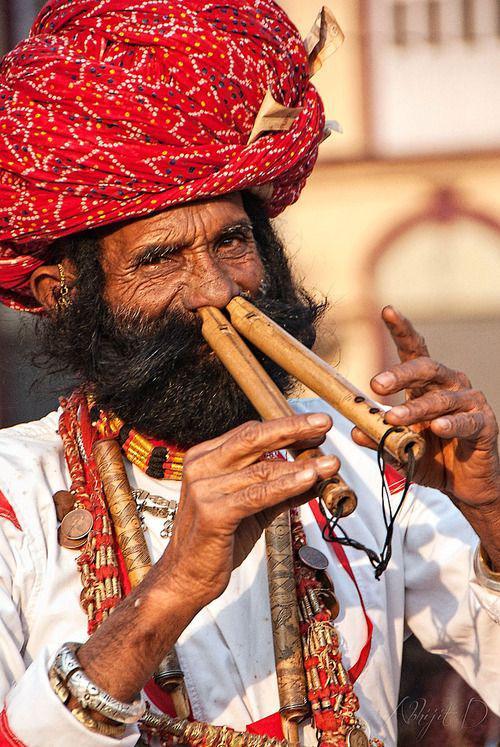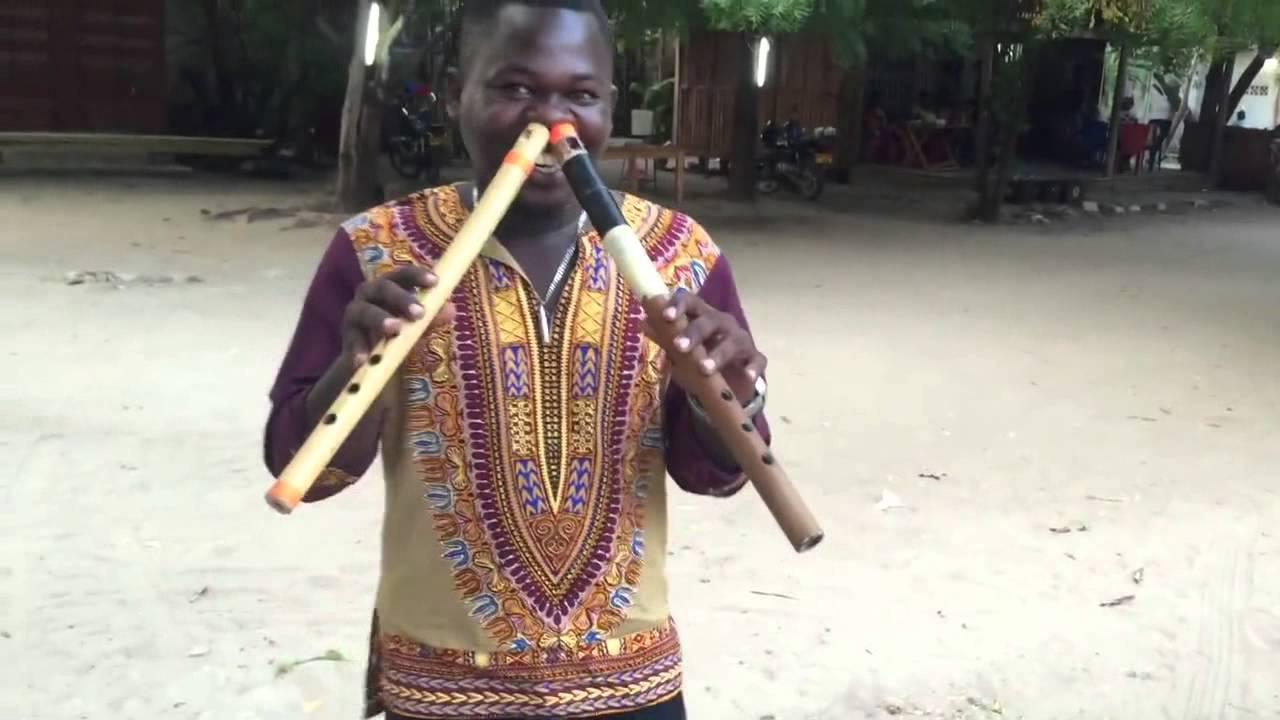The first image is the image on the left, the second image is the image on the right. Evaluate the accuracy of this statement regarding the images: "There is a man playing two nose flutes in each image". Is it true? Answer yes or no. Yes. The first image is the image on the left, the second image is the image on the right. For the images displayed, is the sentence "Each image shows a man holding at least one flute to a nostril, but only the left image features a man in a red turban and bushy dark facial hair holding two flutes to his nostrils." factually correct? Answer yes or no. Yes. 